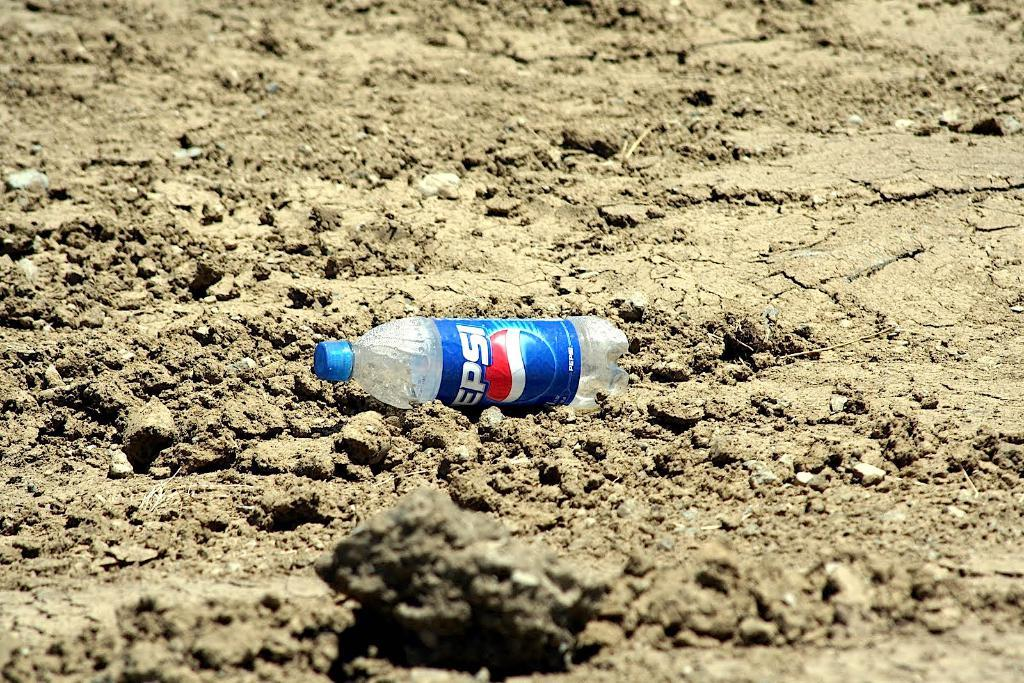What object is on the ground in the image? There is a bottle on the ground. How many books are stacked next to the bottle in the image? There is no mention of any books in the image; it only features a bottle on the ground. 